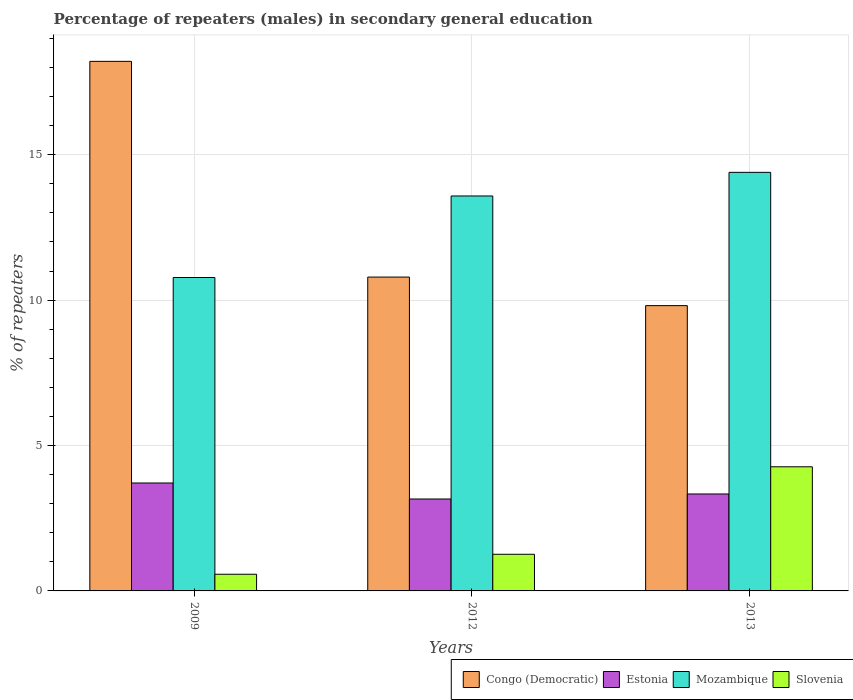How many different coloured bars are there?
Provide a succinct answer. 4. Are the number of bars per tick equal to the number of legend labels?
Offer a very short reply. Yes. Are the number of bars on each tick of the X-axis equal?
Offer a terse response. Yes. In how many cases, is the number of bars for a given year not equal to the number of legend labels?
Keep it short and to the point. 0. What is the percentage of male repeaters in Slovenia in 2013?
Provide a short and direct response. 4.27. Across all years, what is the maximum percentage of male repeaters in Congo (Democratic)?
Provide a succinct answer. 18.21. Across all years, what is the minimum percentage of male repeaters in Estonia?
Your answer should be very brief. 3.16. In which year was the percentage of male repeaters in Slovenia maximum?
Keep it short and to the point. 2013. What is the total percentage of male repeaters in Estonia in the graph?
Make the answer very short. 10.21. What is the difference between the percentage of male repeaters in Congo (Democratic) in 2009 and that in 2012?
Your response must be concise. 7.42. What is the difference between the percentage of male repeaters in Estonia in 2009 and the percentage of male repeaters in Congo (Democratic) in 2012?
Your answer should be very brief. -7.08. What is the average percentage of male repeaters in Estonia per year?
Offer a very short reply. 3.4. In the year 2012, what is the difference between the percentage of male repeaters in Mozambique and percentage of male repeaters in Estonia?
Keep it short and to the point. 10.42. What is the ratio of the percentage of male repeaters in Estonia in 2009 to that in 2012?
Offer a terse response. 1.17. Is the difference between the percentage of male repeaters in Mozambique in 2012 and 2013 greater than the difference between the percentage of male repeaters in Estonia in 2012 and 2013?
Provide a succinct answer. No. What is the difference between the highest and the second highest percentage of male repeaters in Estonia?
Provide a short and direct response. 0.38. What is the difference between the highest and the lowest percentage of male repeaters in Congo (Democratic)?
Make the answer very short. 8.4. In how many years, is the percentage of male repeaters in Slovenia greater than the average percentage of male repeaters in Slovenia taken over all years?
Provide a succinct answer. 1. Is the sum of the percentage of male repeaters in Congo (Democratic) in 2009 and 2013 greater than the maximum percentage of male repeaters in Mozambique across all years?
Offer a very short reply. Yes. What does the 3rd bar from the left in 2012 represents?
Your response must be concise. Mozambique. What does the 2nd bar from the right in 2013 represents?
Offer a terse response. Mozambique. Is it the case that in every year, the sum of the percentage of male repeaters in Congo (Democratic) and percentage of male repeaters in Mozambique is greater than the percentage of male repeaters in Slovenia?
Your answer should be very brief. Yes. How many bars are there?
Ensure brevity in your answer.  12. How many years are there in the graph?
Offer a very short reply. 3. Does the graph contain any zero values?
Offer a terse response. No. How many legend labels are there?
Provide a short and direct response. 4. What is the title of the graph?
Provide a succinct answer. Percentage of repeaters (males) in secondary general education. What is the label or title of the X-axis?
Give a very brief answer. Years. What is the label or title of the Y-axis?
Provide a short and direct response. % of repeaters. What is the % of repeaters of Congo (Democratic) in 2009?
Provide a succinct answer. 18.21. What is the % of repeaters of Estonia in 2009?
Keep it short and to the point. 3.71. What is the % of repeaters in Mozambique in 2009?
Your response must be concise. 10.78. What is the % of repeaters of Slovenia in 2009?
Your response must be concise. 0.57. What is the % of repeaters in Congo (Democratic) in 2012?
Your answer should be very brief. 10.79. What is the % of repeaters of Estonia in 2012?
Give a very brief answer. 3.16. What is the % of repeaters in Mozambique in 2012?
Offer a very short reply. 13.58. What is the % of repeaters in Slovenia in 2012?
Ensure brevity in your answer.  1.26. What is the % of repeaters of Congo (Democratic) in 2013?
Your answer should be very brief. 9.81. What is the % of repeaters of Estonia in 2013?
Your answer should be very brief. 3.33. What is the % of repeaters in Mozambique in 2013?
Provide a succinct answer. 14.39. What is the % of repeaters of Slovenia in 2013?
Provide a succinct answer. 4.27. Across all years, what is the maximum % of repeaters of Congo (Democratic)?
Keep it short and to the point. 18.21. Across all years, what is the maximum % of repeaters in Estonia?
Your response must be concise. 3.71. Across all years, what is the maximum % of repeaters in Mozambique?
Ensure brevity in your answer.  14.39. Across all years, what is the maximum % of repeaters of Slovenia?
Keep it short and to the point. 4.27. Across all years, what is the minimum % of repeaters in Congo (Democratic)?
Your answer should be compact. 9.81. Across all years, what is the minimum % of repeaters of Estonia?
Offer a terse response. 3.16. Across all years, what is the minimum % of repeaters in Mozambique?
Keep it short and to the point. 10.78. Across all years, what is the minimum % of repeaters of Slovenia?
Make the answer very short. 0.57. What is the total % of repeaters of Congo (Democratic) in the graph?
Provide a succinct answer. 38.81. What is the total % of repeaters of Estonia in the graph?
Offer a terse response. 10.21. What is the total % of repeaters in Mozambique in the graph?
Make the answer very short. 38.75. What is the total % of repeaters in Slovenia in the graph?
Give a very brief answer. 6.1. What is the difference between the % of repeaters in Congo (Democratic) in 2009 and that in 2012?
Give a very brief answer. 7.42. What is the difference between the % of repeaters in Estonia in 2009 and that in 2012?
Keep it short and to the point. 0.55. What is the difference between the % of repeaters of Mozambique in 2009 and that in 2012?
Your response must be concise. -2.8. What is the difference between the % of repeaters of Slovenia in 2009 and that in 2012?
Provide a succinct answer. -0.69. What is the difference between the % of repeaters of Congo (Democratic) in 2009 and that in 2013?
Your answer should be very brief. 8.4. What is the difference between the % of repeaters in Estonia in 2009 and that in 2013?
Provide a succinct answer. 0.38. What is the difference between the % of repeaters in Mozambique in 2009 and that in 2013?
Your answer should be very brief. -3.62. What is the difference between the % of repeaters of Slovenia in 2009 and that in 2013?
Give a very brief answer. -3.69. What is the difference between the % of repeaters of Estonia in 2012 and that in 2013?
Give a very brief answer. -0.17. What is the difference between the % of repeaters in Mozambique in 2012 and that in 2013?
Your answer should be compact. -0.81. What is the difference between the % of repeaters in Slovenia in 2012 and that in 2013?
Keep it short and to the point. -3.01. What is the difference between the % of repeaters of Congo (Democratic) in 2009 and the % of repeaters of Estonia in 2012?
Your answer should be compact. 15.05. What is the difference between the % of repeaters of Congo (Democratic) in 2009 and the % of repeaters of Mozambique in 2012?
Your answer should be compact. 4.63. What is the difference between the % of repeaters of Congo (Democratic) in 2009 and the % of repeaters of Slovenia in 2012?
Keep it short and to the point. 16.95. What is the difference between the % of repeaters in Estonia in 2009 and the % of repeaters in Mozambique in 2012?
Your answer should be very brief. -9.87. What is the difference between the % of repeaters in Estonia in 2009 and the % of repeaters in Slovenia in 2012?
Provide a succinct answer. 2.45. What is the difference between the % of repeaters of Mozambique in 2009 and the % of repeaters of Slovenia in 2012?
Make the answer very short. 9.52. What is the difference between the % of repeaters of Congo (Democratic) in 2009 and the % of repeaters of Estonia in 2013?
Your answer should be compact. 14.88. What is the difference between the % of repeaters of Congo (Democratic) in 2009 and the % of repeaters of Mozambique in 2013?
Your answer should be compact. 3.82. What is the difference between the % of repeaters of Congo (Democratic) in 2009 and the % of repeaters of Slovenia in 2013?
Keep it short and to the point. 13.94. What is the difference between the % of repeaters of Estonia in 2009 and the % of repeaters of Mozambique in 2013?
Keep it short and to the point. -10.68. What is the difference between the % of repeaters in Estonia in 2009 and the % of repeaters in Slovenia in 2013?
Your answer should be very brief. -0.56. What is the difference between the % of repeaters in Mozambique in 2009 and the % of repeaters in Slovenia in 2013?
Offer a very short reply. 6.51. What is the difference between the % of repeaters of Congo (Democratic) in 2012 and the % of repeaters of Estonia in 2013?
Give a very brief answer. 7.46. What is the difference between the % of repeaters of Congo (Democratic) in 2012 and the % of repeaters of Mozambique in 2013?
Provide a succinct answer. -3.6. What is the difference between the % of repeaters of Congo (Democratic) in 2012 and the % of repeaters of Slovenia in 2013?
Give a very brief answer. 6.52. What is the difference between the % of repeaters in Estonia in 2012 and the % of repeaters in Mozambique in 2013?
Your answer should be very brief. -11.23. What is the difference between the % of repeaters of Estonia in 2012 and the % of repeaters of Slovenia in 2013?
Your answer should be compact. -1.11. What is the difference between the % of repeaters in Mozambique in 2012 and the % of repeaters in Slovenia in 2013?
Give a very brief answer. 9.31. What is the average % of repeaters in Congo (Democratic) per year?
Your answer should be compact. 12.94. What is the average % of repeaters of Estonia per year?
Your response must be concise. 3.4. What is the average % of repeaters in Mozambique per year?
Your answer should be compact. 12.92. What is the average % of repeaters in Slovenia per year?
Give a very brief answer. 2.03. In the year 2009, what is the difference between the % of repeaters of Congo (Democratic) and % of repeaters of Estonia?
Provide a succinct answer. 14.5. In the year 2009, what is the difference between the % of repeaters in Congo (Democratic) and % of repeaters in Mozambique?
Provide a succinct answer. 7.43. In the year 2009, what is the difference between the % of repeaters in Congo (Democratic) and % of repeaters in Slovenia?
Keep it short and to the point. 17.64. In the year 2009, what is the difference between the % of repeaters in Estonia and % of repeaters in Mozambique?
Your answer should be compact. -7.07. In the year 2009, what is the difference between the % of repeaters of Estonia and % of repeaters of Slovenia?
Keep it short and to the point. 3.14. In the year 2009, what is the difference between the % of repeaters of Mozambique and % of repeaters of Slovenia?
Give a very brief answer. 10.2. In the year 2012, what is the difference between the % of repeaters of Congo (Democratic) and % of repeaters of Estonia?
Your answer should be compact. 7.63. In the year 2012, what is the difference between the % of repeaters of Congo (Democratic) and % of repeaters of Mozambique?
Keep it short and to the point. -2.79. In the year 2012, what is the difference between the % of repeaters of Congo (Democratic) and % of repeaters of Slovenia?
Make the answer very short. 9.53. In the year 2012, what is the difference between the % of repeaters of Estonia and % of repeaters of Mozambique?
Keep it short and to the point. -10.42. In the year 2012, what is the difference between the % of repeaters in Estonia and % of repeaters in Slovenia?
Provide a short and direct response. 1.9. In the year 2012, what is the difference between the % of repeaters of Mozambique and % of repeaters of Slovenia?
Your answer should be very brief. 12.32. In the year 2013, what is the difference between the % of repeaters of Congo (Democratic) and % of repeaters of Estonia?
Provide a succinct answer. 6.48. In the year 2013, what is the difference between the % of repeaters in Congo (Democratic) and % of repeaters in Mozambique?
Ensure brevity in your answer.  -4.58. In the year 2013, what is the difference between the % of repeaters in Congo (Democratic) and % of repeaters in Slovenia?
Your answer should be very brief. 5.54. In the year 2013, what is the difference between the % of repeaters in Estonia and % of repeaters in Mozambique?
Keep it short and to the point. -11.06. In the year 2013, what is the difference between the % of repeaters of Estonia and % of repeaters of Slovenia?
Offer a very short reply. -0.94. In the year 2013, what is the difference between the % of repeaters of Mozambique and % of repeaters of Slovenia?
Offer a very short reply. 10.12. What is the ratio of the % of repeaters in Congo (Democratic) in 2009 to that in 2012?
Your answer should be very brief. 1.69. What is the ratio of the % of repeaters of Estonia in 2009 to that in 2012?
Keep it short and to the point. 1.17. What is the ratio of the % of repeaters of Mozambique in 2009 to that in 2012?
Ensure brevity in your answer.  0.79. What is the ratio of the % of repeaters in Slovenia in 2009 to that in 2012?
Ensure brevity in your answer.  0.46. What is the ratio of the % of repeaters of Congo (Democratic) in 2009 to that in 2013?
Offer a very short reply. 1.86. What is the ratio of the % of repeaters of Estonia in 2009 to that in 2013?
Ensure brevity in your answer.  1.11. What is the ratio of the % of repeaters in Mozambique in 2009 to that in 2013?
Your answer should be compact. 0.75. What is the ratio of the % of repeaters of Slovenia in 2009 to that in 2013?
Your answer should be very brief. 0.13. What is the ratio of the % of repeaters of Congo (Democratic) in 2012 to that in 2013?
Offer a terse response. 1.1. What is the ratio of the % of repeaters in Estonia in 2012 to that in 2013?
Make the answer very short. 0.95. What is the ratio of the % of repeaters in Mozambique in 2012 to that in 2013?
Your response must be concise. 0.94. What is the ratio of the % of repeaters of Slovenia in 2012 to that in 2013?
Provide a succinct answer. 0.3. What is the difference between the highest and the second highest % of repeaters of Congo (Democratic)?
Offer a terse response. 7.42. What is the difference between the highest and the second highest % of repeaters in Estonia?
Offer a very short reply. 0.38. What is the difference between the highest and the second highest % of repeaters of Mozambique?
Your answer should be very brief. 0.81. What is the difference between the highest and the second highest % of repeaters of Slovenia?
Provide a short and direct response. 3.01. What is the difference between the highest and the lowest % of repeaters of Congo (Democratic)?
Provide a succinct answer. 8.4. What is the difference between the highest and the lowest % of repeaters of Estonia?
Your answer should be compact. 0.55. What is the difference between the highest and the lowest % of repeaters of Mozambique?
Keep it short and to the point. 3.62. What is the difference between the highest and the lowest % of repeaters in Slovenia?
Give a very brief answer. 3.69. 